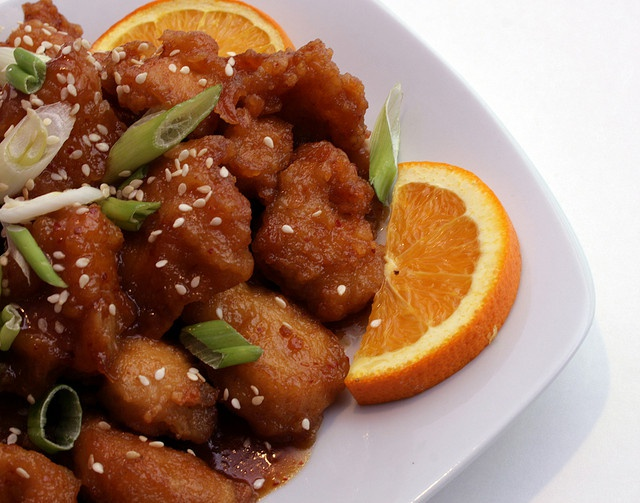Describe the objects in this image and their specific colors. I can see orange in white, orange, and khaki tones and orange in white, orange, and tan tones in this image. 